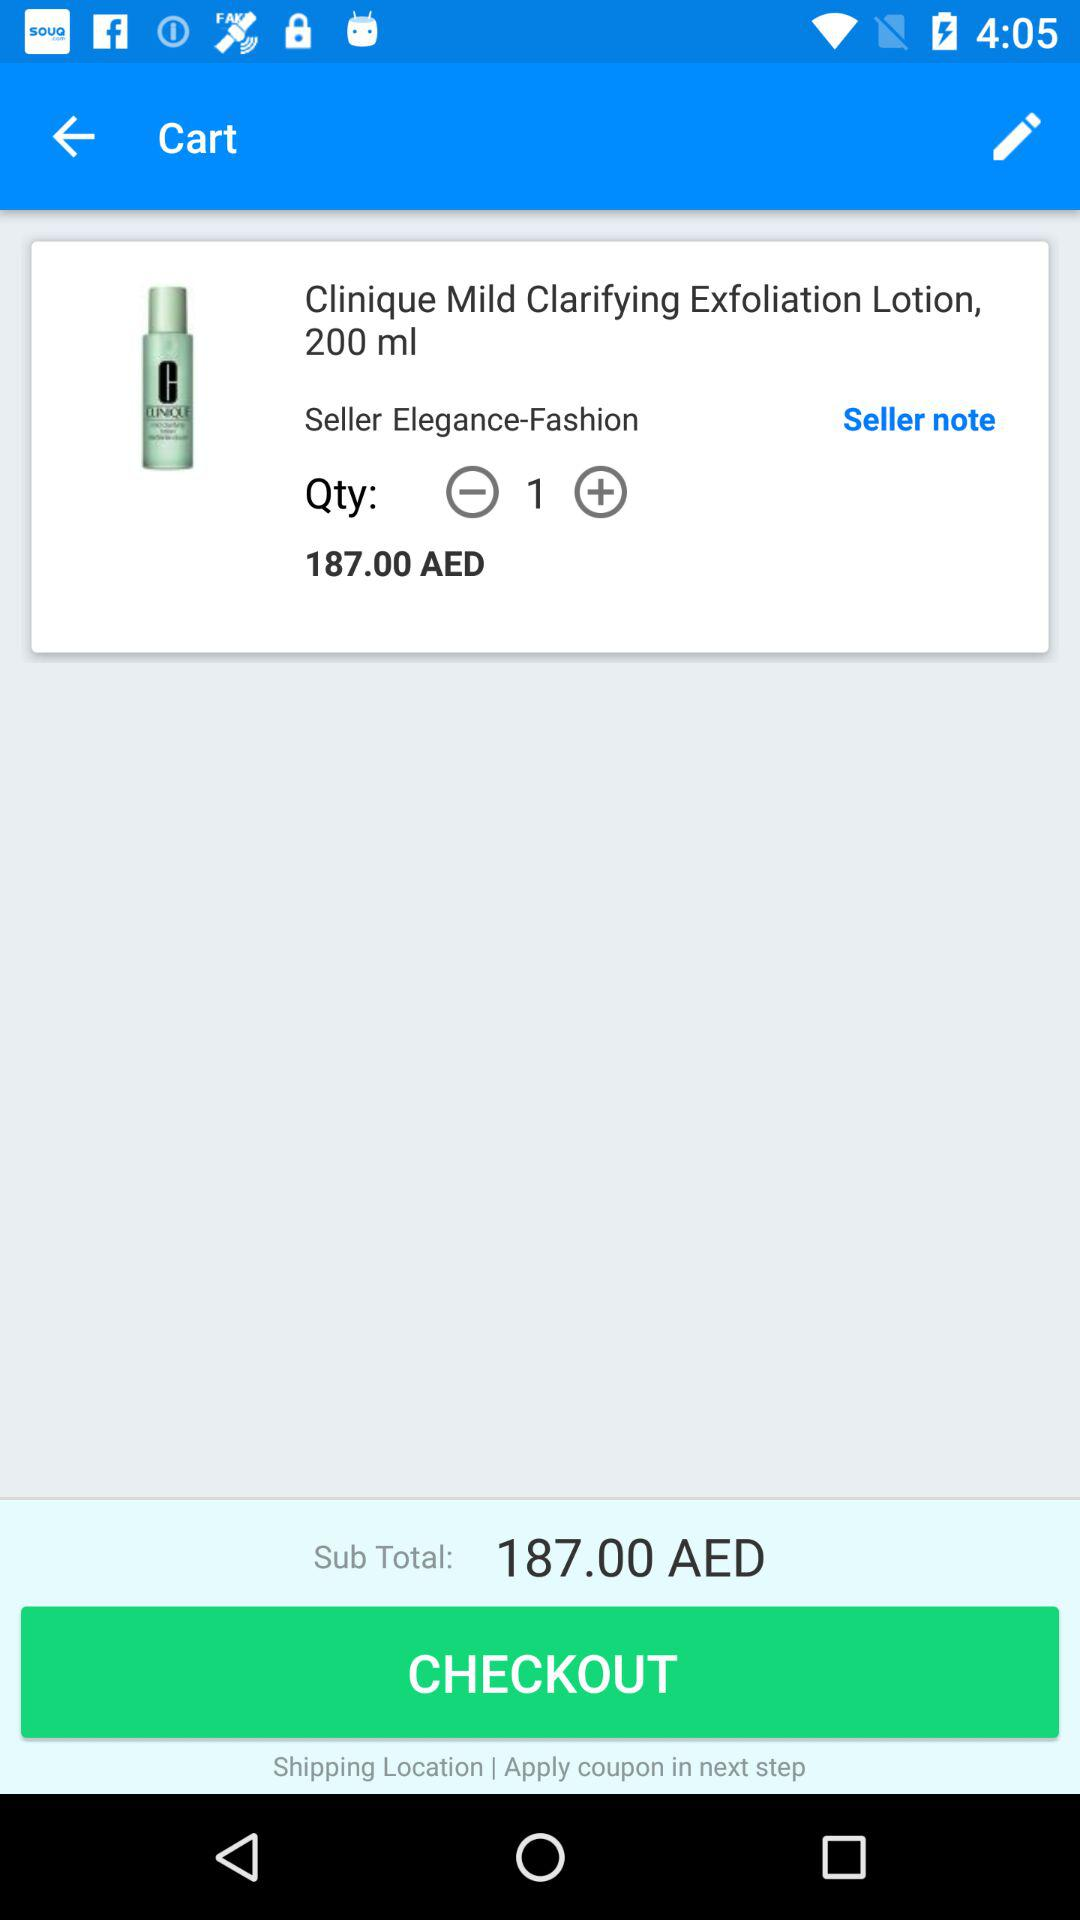How many items are in the cart?
Answer the question using a single word or phrase. 1 